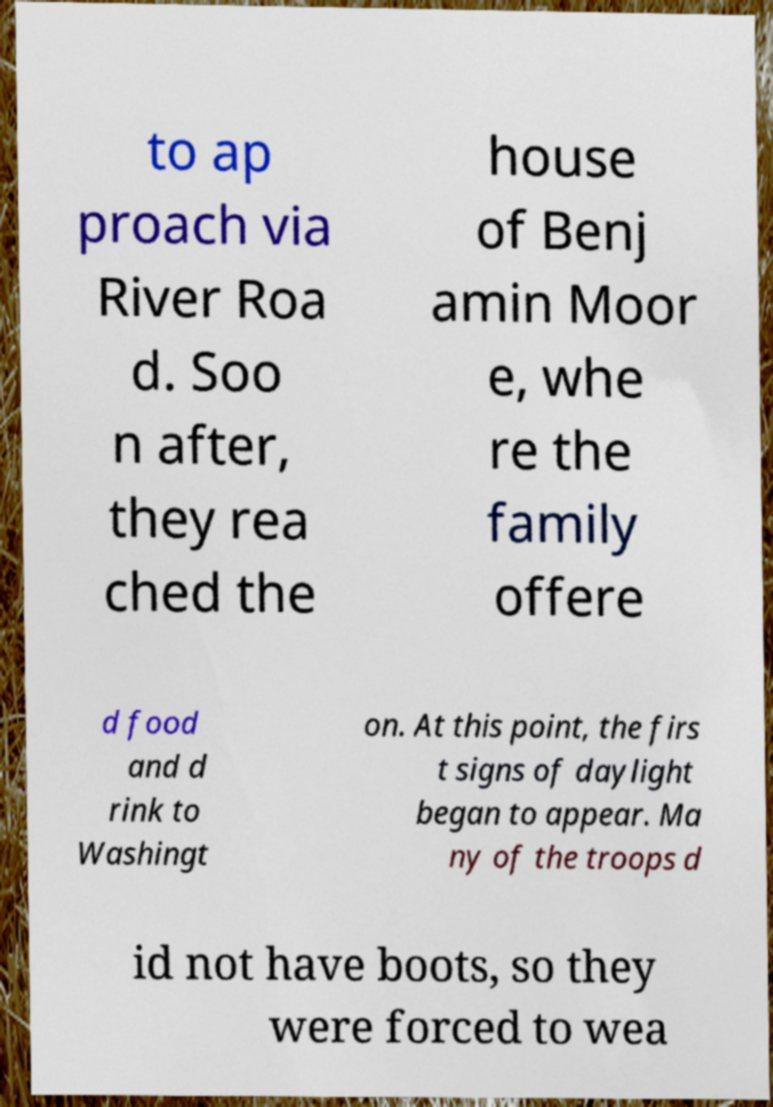Could you extract and type out the text from this image? to ap proach via River Roa d. Soo n after, they rea ched the house of Benj amin Moor e, whe re the family offere d food and d rink to Washingt on. At this point, the firs t signs of daylight began to appear. Ma ny of the troops d id not have boots, so they were forced to wea 